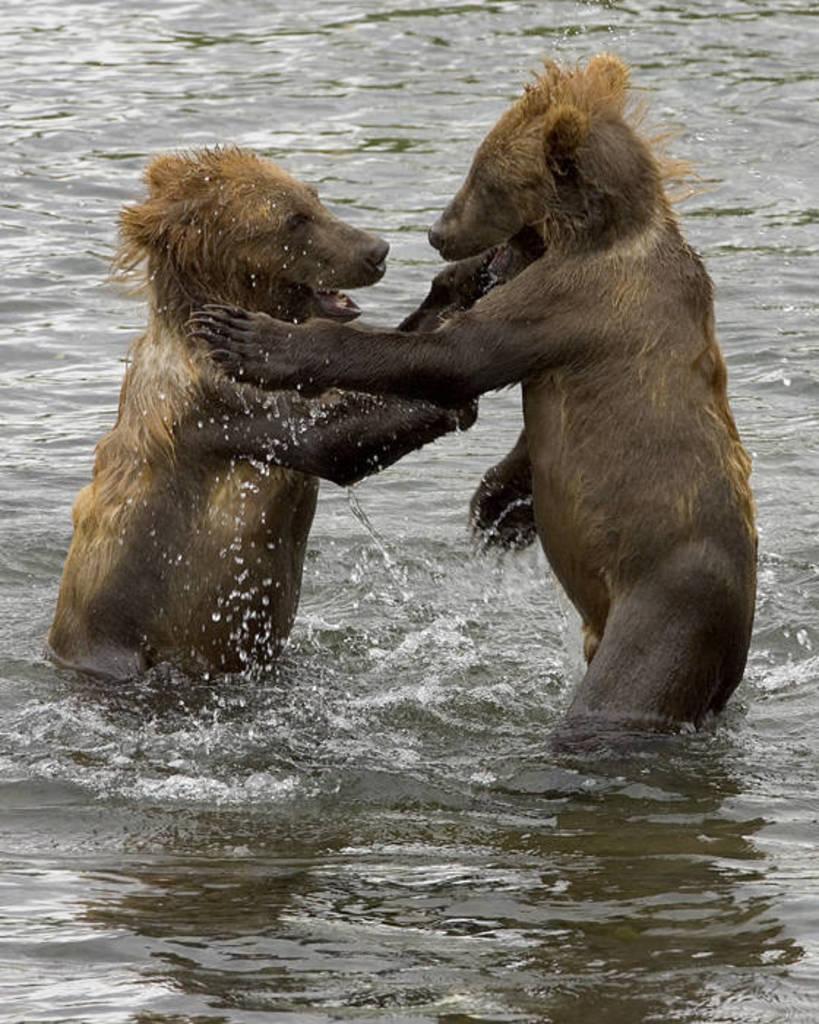Describe this image in one or two sentences. In the foreground of this image, there are two bears in the water. 